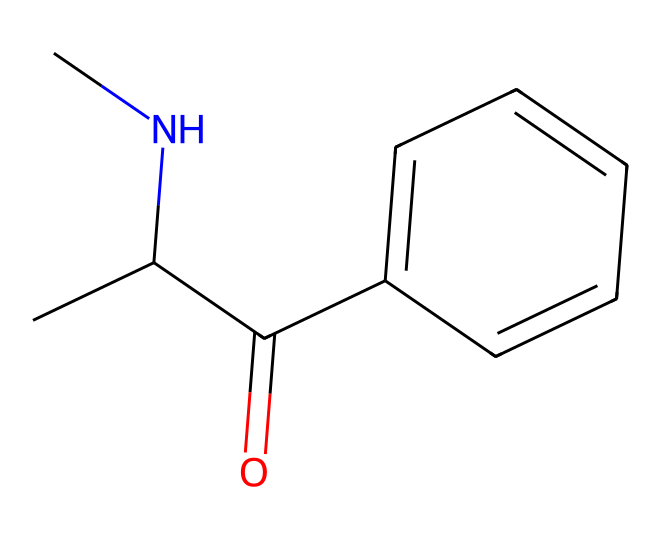What is the molecular formula represented by this chemical? The molecular formula can be derived from counting the number of each type of atom in the SMILES notation. For the given SMILES, we have 11 carbon (C), 13 hydrogen (H), 1 nitrogen (N), and 1 oxygen (O) atom. Therefore, the molecular formula is C11H13N1O1.
Answer: C11H13NO How many rings are present in the structure? Analyzing the SMILES representation, I look for the cyclic structures denoted by the numbering. There are no numbered rings in this molecule, indicating that it has no rings.
Answer: 0 What type of bonding is likely predominant in this structure? The presence of carbon, nitrogen, and oxygen atoms suggests covalent bonding is predominant. The high electronegativity difference between oxygen and carbon/nitrogen also indicates that polar covalent bonds are present.
Answer: covalent Is this molecule likely to be hydrophilic or hydrophobic? The presence of the nitrogen and oxygen atoms suggests the molecule has polar characteristics, which typically leads to hydrophilic properties. This is due to the ability of these atoms to form hydrogen bonds with water.
Answer: hydrophilic What functional group does this molecule contain? In reviewing the structure, I see that it contains an amine group (–NH) and a carbonyl group (C=O) which indicates the presence of an amide functional group. This is confirmed by reviewing the structure of the molecule.
Answer: amide What is the approximate molecular weight of this compound? To find the molecular weight, I sum the atomic weights of all atoms in the molecular formula. For C (12.01 g/mol), H (1.008 g/mol), N (14.01 g/mol), O (16.00 g/mol), the calculation gives the approximate molecular weight of 175 g/mol.
Answer: 175 